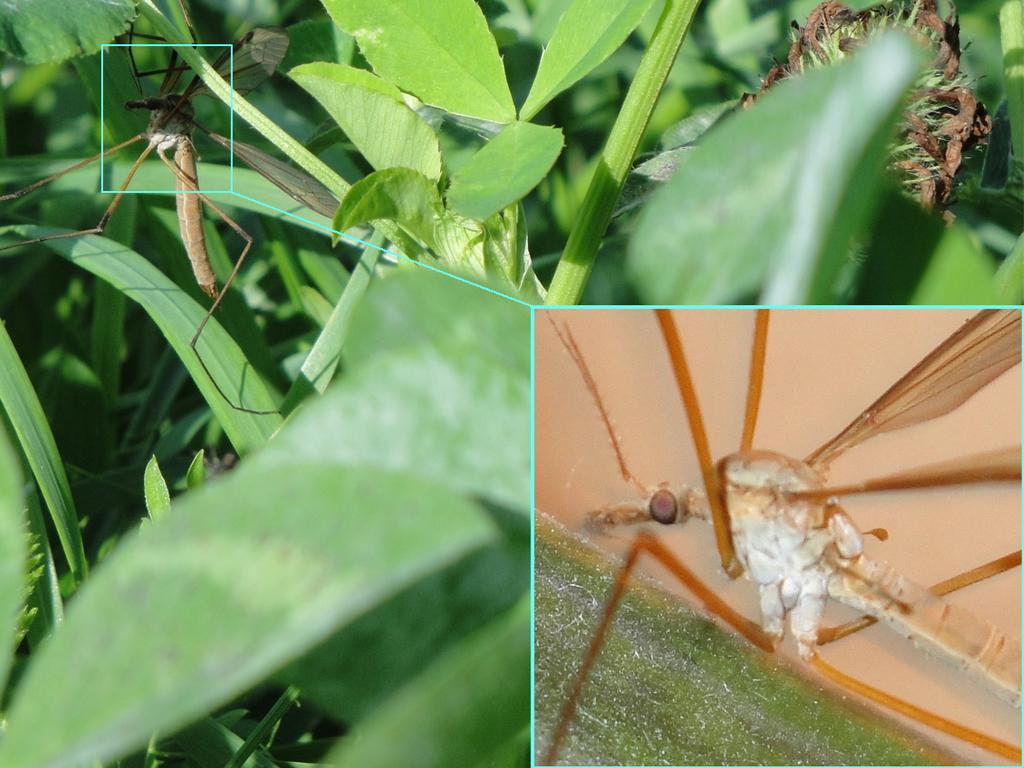Please provide a concise description of this image. In this picture we observe a insect which is on the leaf and there is a zoomed photograph of the insect to the right side. 